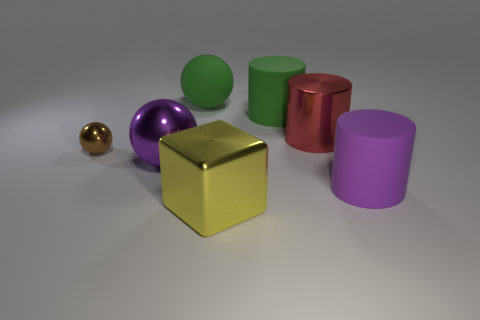Subtract all cyan cubes. Subtract all gray spheres. How many cubes are left? 1 Add 3 cubes. How many objects exist? 10 Subtract all cylinders. How many objects are left? 4 Add 5 large yellow metal objects. How many large yellow metal objects exist? 6 Subtract 0 purple cubes. How many objects are left? 7 Subtract all big rubber balls. Subtract all balls. How many objects are left? 3 Add 6 brown metal things. How many brown metal things are left? 7 